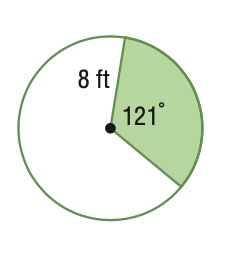Question: Find the area of the sector. Round to the nearest tenth.
Choices:
A. 16.9
B. 67.6
C. 133.5
D. 201.1
Answer with the letter. Answer: B 